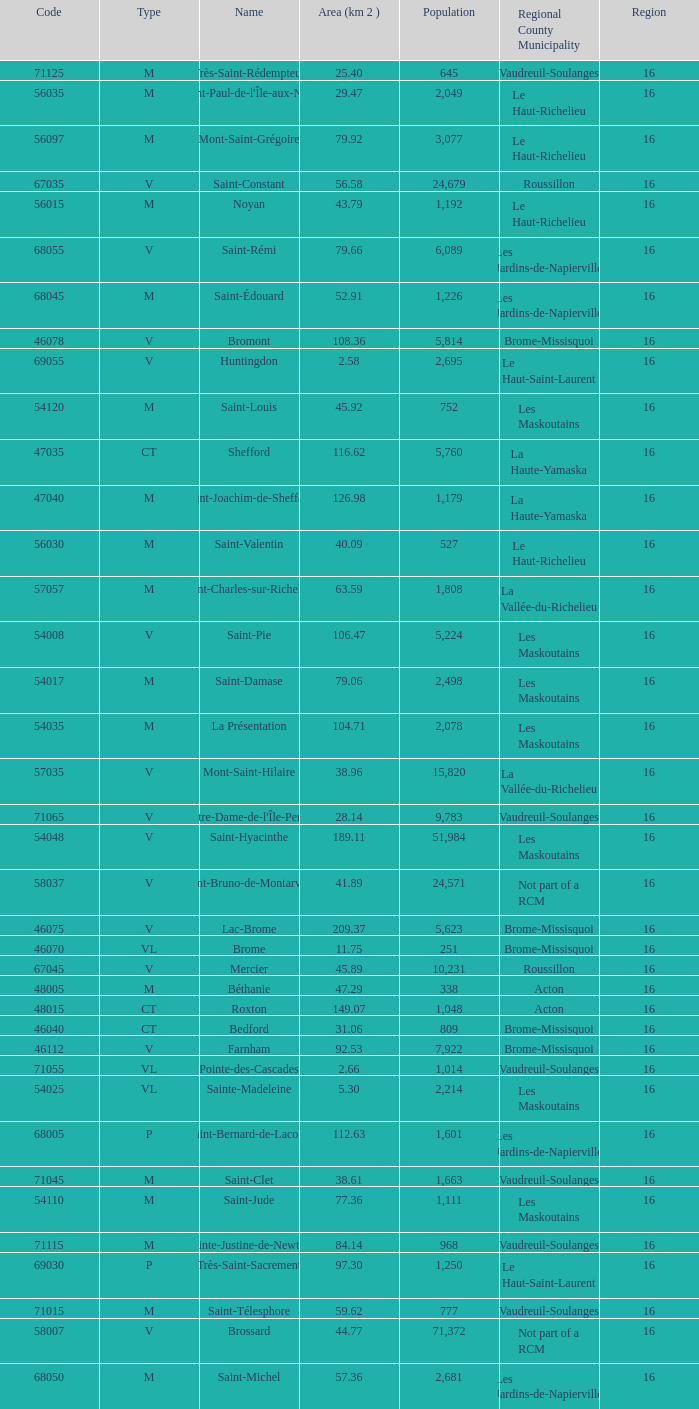What is the code for a Le Haut-Saint-Laurent municipality that has 16 or more regions? None. 